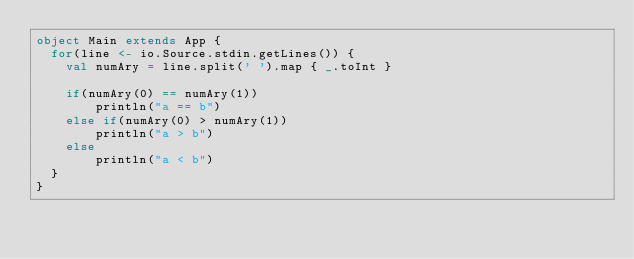Convert code to text. <code><loc_0><loc_0><loc_500><loc_500><_Scala_>object Main extends App {
  for(line <- io.Source.stdin.getLines()) {
    val numAry = line.split(' ').map { _.toInt }
    
    if(numAry(0) == numAry(1))
        println("a == b")
    else if(numAry(0) > numAry(1))
        println("a > b")
    else
        println("a < b")
  }
}
</code> 